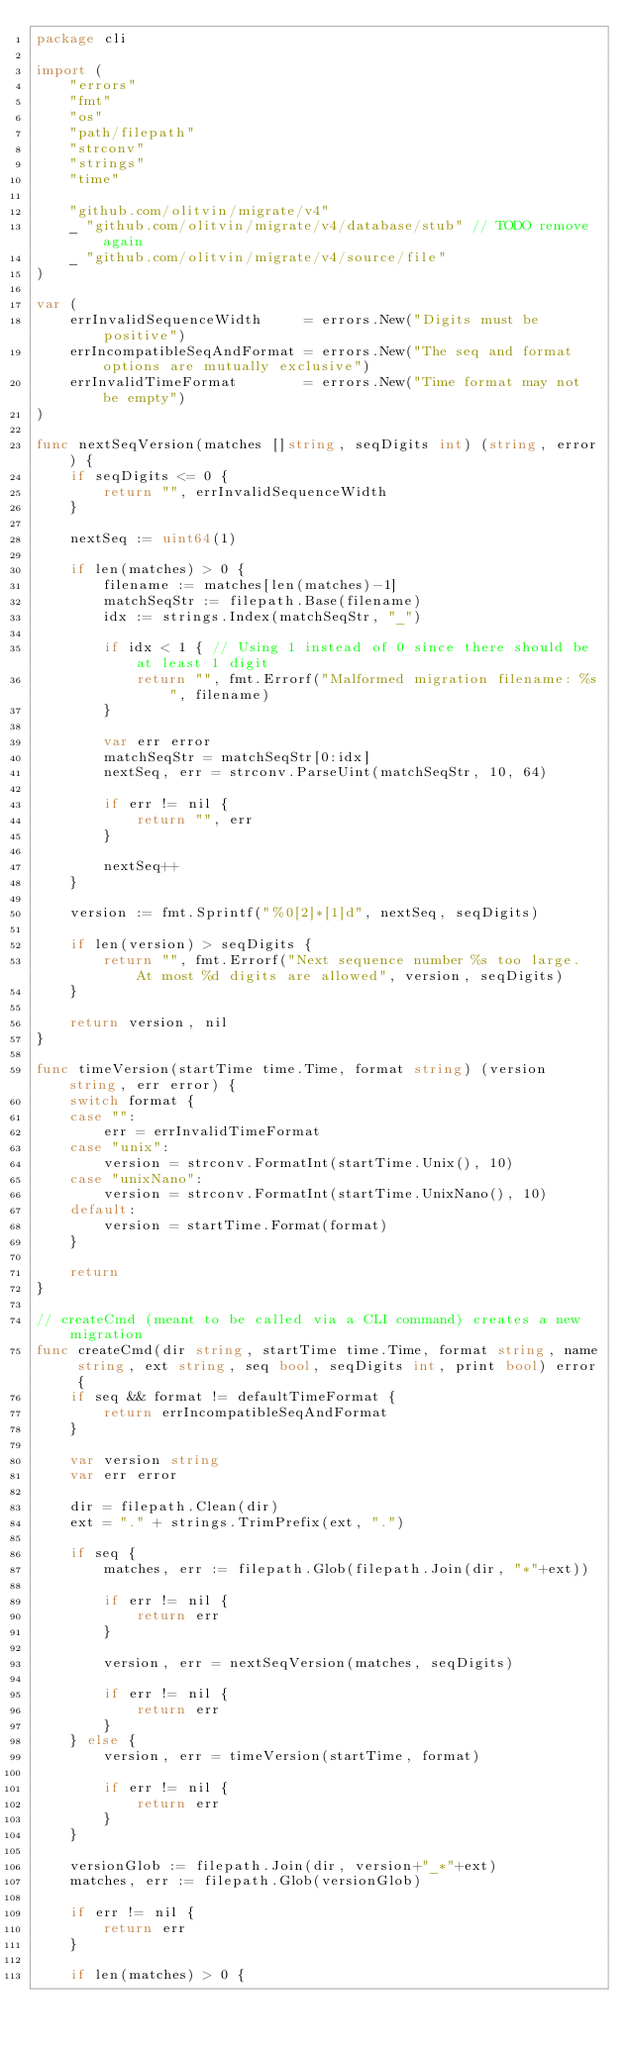Convert code to text. <code><loc_0><loc_0><loc_500><loc_500><_Go_>package cli

import (
	"errors"
	"fmt"
	"os"
	"path/filepath"
	"strconv"
	"strings"
	"time"

	"github.com/olitvin/migrate/v4"
	_ "github.com/olitvin/migrate/v4/database/stub" // TODO remove again
	_ "github.com/olitvin/migrate/v4/source/file"
)

var (
	errInvalidSequenceWidth     = errors.New("Digits must be positive")
	errIncompatibleSeqAndFormat = errors.New("The seq and format options are mutually exclusive")
	errInvalidTimeFormat        = errors.New("Time format may not be empty")
)

func nextSeqVersion(matches []string, seqDigits int) (string, error) {
	if seqDigits <= 0 {
		return "", errInvalidSequenceWidth
	}

	nextSeq := uint64(1)

	if len(matches) > 0 {
		filename := matches[len(matches)-1]
		matchSeqStr := filepath.Base(filename)
		idx := strings.Index(matchSeqStr, "_")

		if idx < 1 { // Using 1 instead of 0 since there should be at least 1 digit
			return "", fmt.Errorf("Malformed migration filename: %s", filename)
		}

		var err error
		matchSeqStr = matchSeqStr[0:idx]
		nextSeq, err = strconv.ParseUint(matchSeqStr, 10, 64)

		if err != nil {
			return "", err
		}

		nextSeq++
	}

	version := fmt.Sprintf("%0[2]*[1]d", nextSeq, seqDigits)

	if len(version) > seqDigits {
		return "", fmt.Errorf("Next sequence number %s too large. At most %d digits are allowed", version, seqDigits)
	}

	return version, nil
}

func timeVersion(startTime time.Time, format string) (version string, err error) {
	switch format {
	case "":
		err = errInvalidTimeFormat
	case "unix":
		version = strconv.FormatInt(startTime.Unix(), 10)
	case "unixNano":
		version = strconv.FormatInt(startTime.UnixNano(), 10)
	default:
		version = startTime.Format(format)
	}

	return
}

// createCmd (meant to be called via a CLI command) creates a new migration
func createCmd(dir string, startTime time.Time, format string, name string, ext string, seq bool, seqDigits int, print bool) error {
	if seq && format != defaultTimeFormat {
		return errIncompatibleSeqAndFormat
	}

	var version string
	var err error

	dir = filepath.Clean(dir)
	ext = "." + strings.TrimPrefix(ext, ".")

	if seq {
		matches, err := filepath.Glob(filepath.Join(dir, "*"+ext))

		if err != nil {
			return err
		}

		version, err = nextSeqVersion(matches, seqDigits)

		if err != nil {
			return err
		}
	} else {
		version, err = timeVersion(startTime, format)

		if err != nil {
			return err
		}
	}

	versionGlob := filepath.Join(dir, version+"_*"+ext)
	matches, err := filepath.Glob(versionGlob)

	if err != nil {
		return err
	}

	if len(matches) > 0 {</code> 